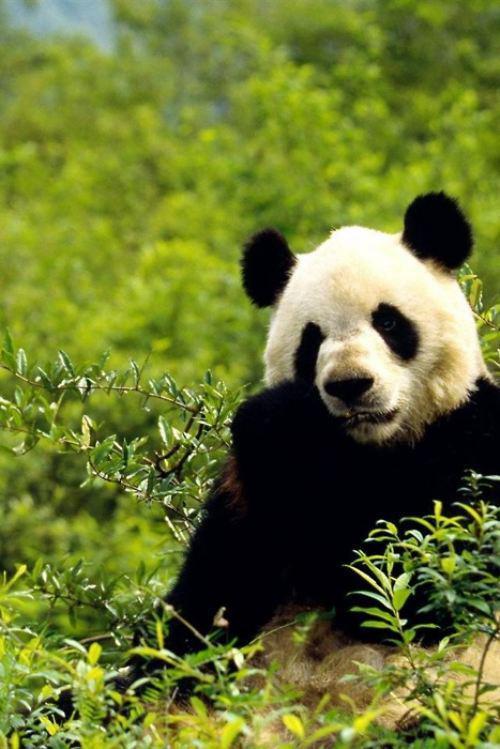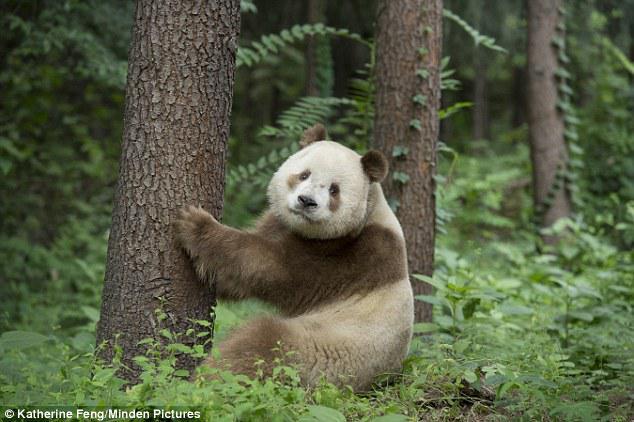The first image is the image on the left, the second image is the image on the right. For the images shown, is this caption "An image shows a brown and white panda surrounded by foliage." true? Answer yes or no. Yes. The first image is the image on the left, the second image is the image on the right. Evaluate the accuracy of this statement regarding the images: "The left image contains a panda chewing on food.". Is it true? Answer yes or no. Yes. 